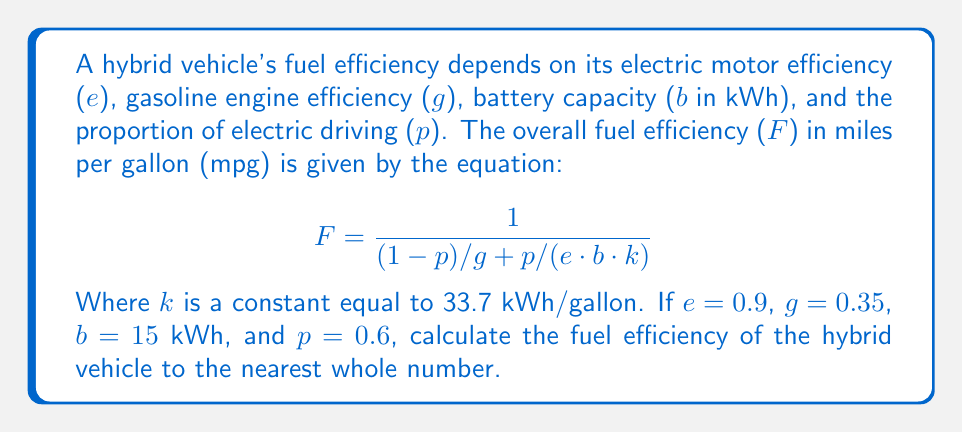Can you answer this question? To solve this problem, we'll follow these steps:

1. Identify the given values:
   $e = 0.9$ (electric motor efficiency)
   $g = 0.35$ (gasoline engine efficiency)
   $b = 15$ kWh (battery capacity)
   $p = 0.6$ (proportion of electric driving)
   $k = 33.7$ kWh/gallon (constant)

2. Substitute these values into the equation:

   $$F = \frac{1}{(1-p)/g + p/(e \cdot b \cdot k)}$$

3. Calculate $(1-p)/g$:
   $$(1-0.6)/0.35 = 0.4/0.35 = 1.1429$$

4. Calculate $p/(e \cdot b \cdot k)$:
   $$0.6/(0.9 \cdot 15 \cdot 33.7) = 0.6/455.95 = 0.001316$$

5. Add the results from steps 3 and 4:
   $$1.1429 + 0.001316 = 1.144216$$

6. Take the reciprocal of this sum:
   $$F = 1/1.144216 = 0.8739$$

7. Convert to miles per gallon:
   $$F = 0.8739 \cdot 100 = 87.39 \text{ mpg}$$

8. Round to the nearest whole number:
   $$F \approx 87 \text{ mpg}$$
Answer: 87 mpg 